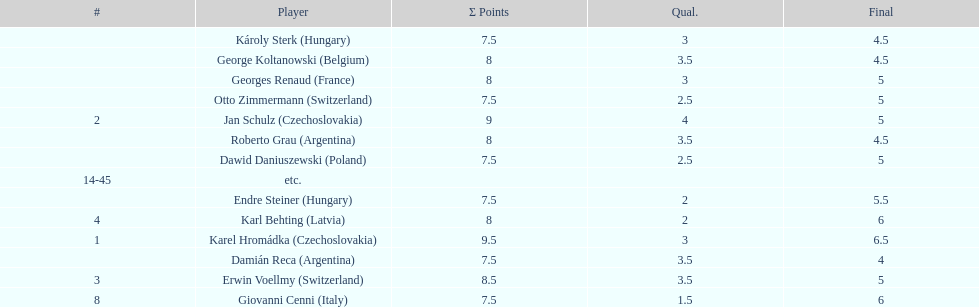Karl behting and giovanni cenni each had final scores of what? 6. 